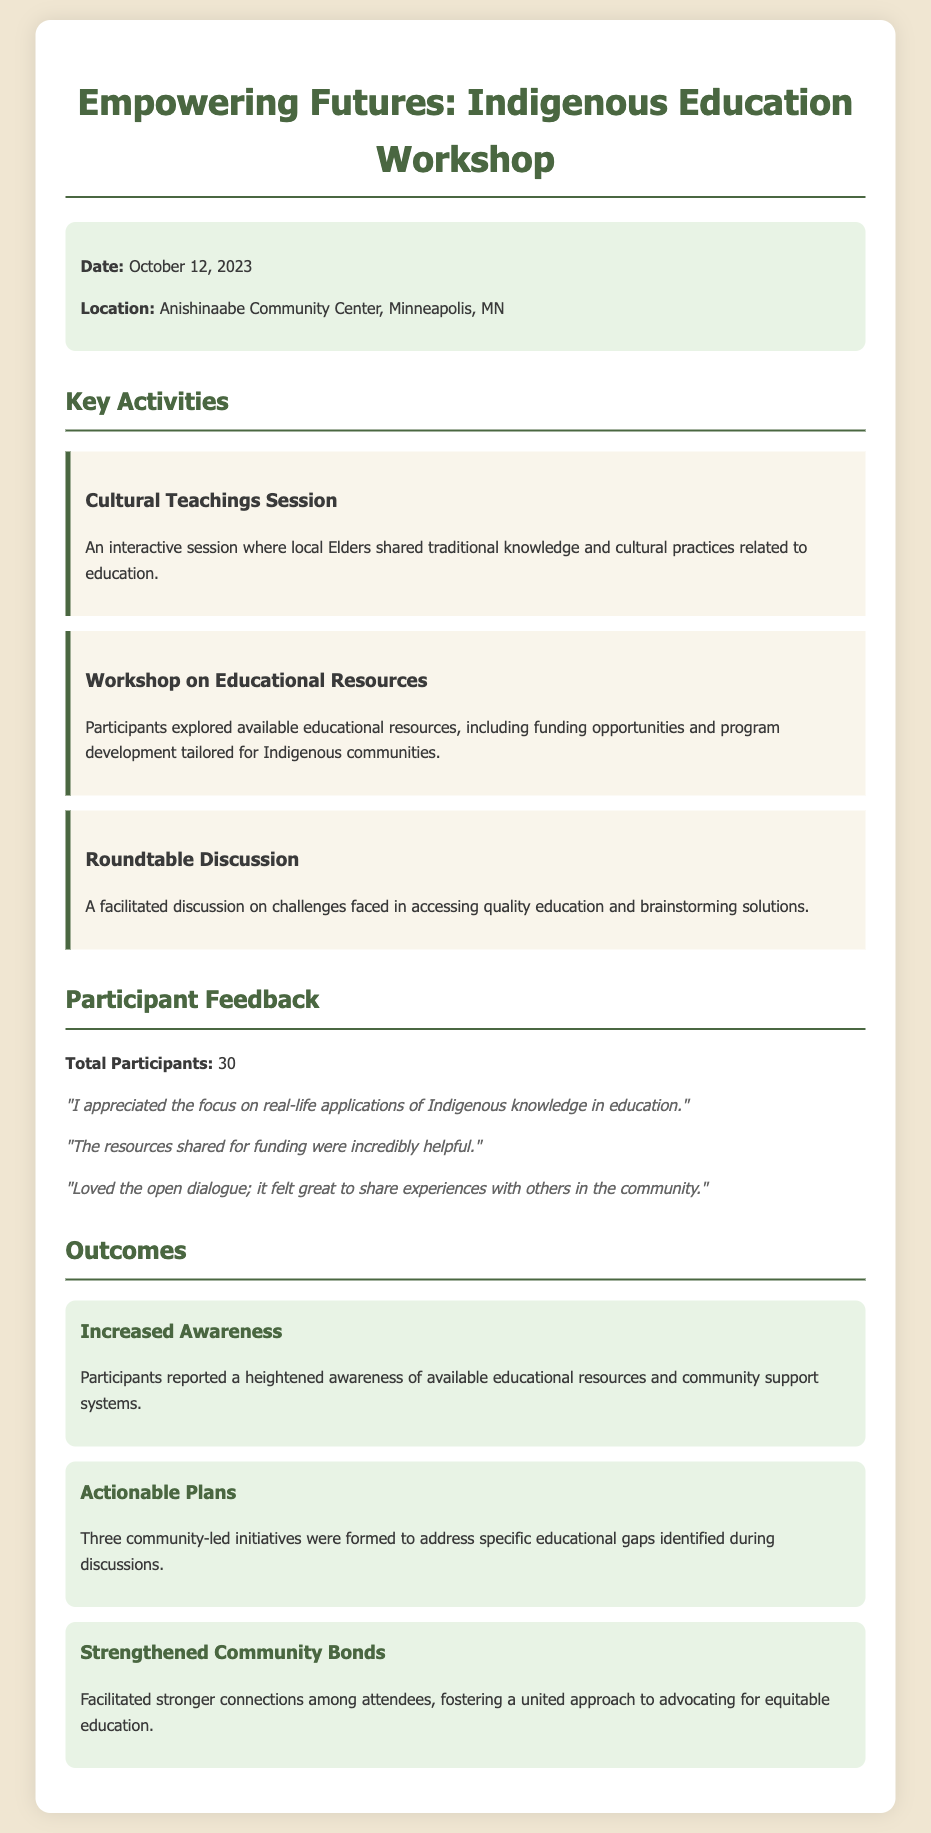What is the date of the workshop? The date of the workshop is mentioned in the event details section.
Answer: October 12, 2023 Where was the workshop held? The location of the workshop is specified in the event details.
Answer: Anishinaabe Community Center, Minneapolis, MN How many total participants attended the workshop? The total number of participants is stated in the participant feedback section.
Answer: 30 What was one of the key activities during the workshop? The document highlights several key activities; one is provided in the activities section.
Answer: Cultural Teachings Session What outcome relates to community connection? The outcomes section describes various results from the workshop, including community aspects.
Answer: Strengthened Community Bonds What type of session highlighted traditional knowledge? The activities section includes specific types of sessions, one of which focuses on traditional knowledge.
Answer: Cultural Teachings Session What did participants appreciate regarding funding? Participant feedback includes specific comments related to resources offered during the workshop.
Answer: The resources shared for funding were incredibly helpful Which specific educational gaps were addressed? The outcomes section notes that community-led initiatives were formed to address educational gaps identified.
Answer: Specific educational gaps identified during discussions 